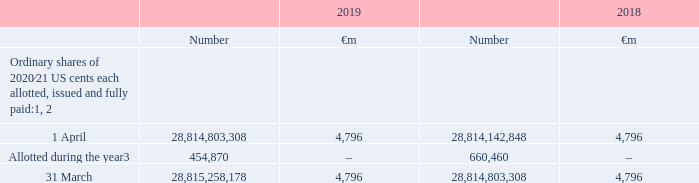6. Called up share capital
Accounting policies
Equity instruments issued by the Company are recorded at the amount of the proceeds received, net of direct issuance costs.
Notes: 1 At 31 March 2019 there were 50,000 (2018: 50,000) 7% cumulative fixed rate shares of £1 each in issue
2 At 31 March 2019 the Group held 1,584,882,610 (2018: 2,139,038,029) treasury shares with a nominal value of €264 million (2018: €356 million). The market value of shares held was €2,566 million (2018: €4,738 million). During the year, 45,657,750 (2018: 53,026,317) treasury shares were reissued under Group share schemes. On 25 August 2017, 729,077,001 treasury shares were issued in settlement of tranche 1 of a maturing subordinated mandatory convertible bond issued on 19 February 2016. On 25 February 2019, 799,067,749 treasury shares were issued in settlement of tranche 2 of the maturing subordinated mandatory convertible bond. On 5 March 2019 the Group announced the placing of subordinated mandatory convertible bonds totalling £1.72 billion with a 2 year maturity date in 2021 and £1.72 billion with a 3 year maturity date due in 2022. The bonds are convertible into a total of 2,547,204,739 ordinary shares with a conversion price of £1.3505 per share. For further details see note 20 “Borrowings and capital resources” in the consolidated financial statements.
3 Represents US share awards and option scheme awards.
Which financial years' information is shown in the table? 2018, 2019. How many shares were allotted as at 31 March 2019? 28,815,258,178. How many shares were allotted as at 31 March 2018? 28,814,803,308. What is the 2019 average amount of ordinary shares as at 1 April? (28,814,803,308+28,814,142,848)/2
Answer: 28814473078. What is the 2019 average amount of ordinary shares as at 31 March? (28,815,258,178+28,814,803,308)/2
Answer: 28815030743. What is the 2019 average amount of ordinary shares allotted during the year? (454,870+660,460)/2
Answer: 557665. 